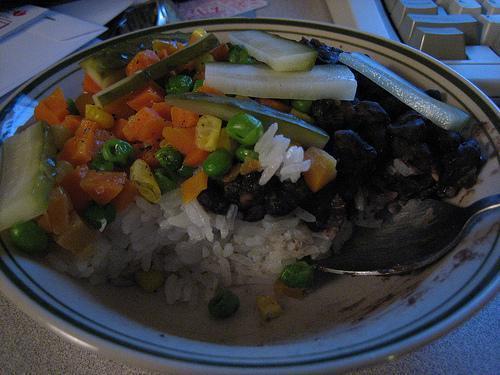How many plates on the table?
Give a very brief answer. 1. 